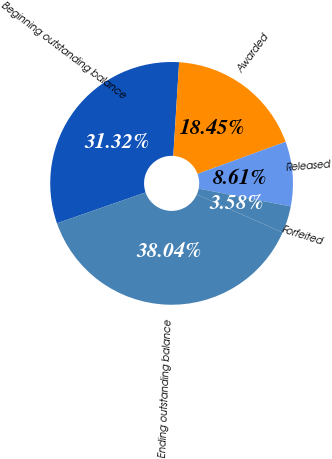Convert chart. <chart><loc_0><loc_0><loc_500><loc_500><pie_chart><fcel>Beginning outstanding balance<fcel>Awarded<fcel>Released<fcel>Forfeited<fcel>Ending outstanding balance<nl><fcel>31.32%<fcel>18.45%<fcel>8.61%<fcel>3.58%<fcel>38.04%<nl></chart> 